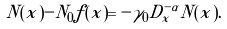<formula> <loc_0><loc_0><loc_500><loc_500>N ( x ) - N _ { 0 } f ( x ) = - \gamma _ { 0 } D ^ { - \alpha } _ { x } N ( x ) .</formula> 